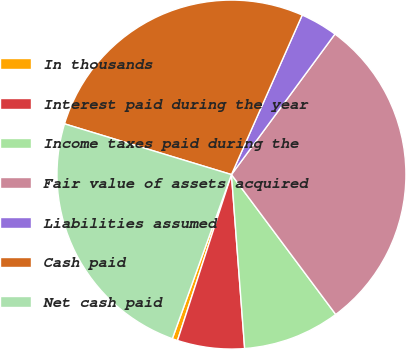Convert chart to OTSL. <chart><loc_0><loc_0><loc_500><loc_500><pie_chart><fcel>In thousands<fcel>Interest paid during the year<fcel>Income taxes paid during the<fcel>Fair value of assets acquired<fcel>Liabilities assumed<fcel>Cash paid<fcel>Net cash paid<nl><fcel>0.5%<fcel>6.21%<fcel>8.99%<fcel>29.7%<fcel>3.46%<fcel>26.95%<fcel>24.19%<nl></chart> 